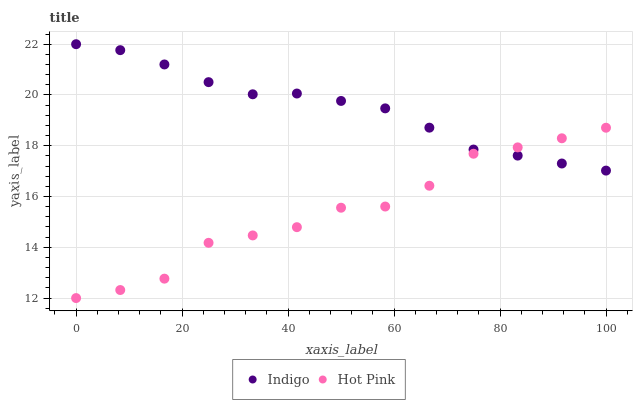Does Hot Pink have the minimum area under the curve?
Answer yes or no. Yes. Does Indigo have the maximum area under the curve?
Answer yes or no. Yes. Does Indigo have the minimum area under the curve?
Answer yes or no. No. Is Indigo the smoothest?
Answer yes or no. Yes. Is Hot Pink the roughest?
Answer yes or no. Yes. Is Indigo the roughest?
Answer yes or no. No. Does Hot Pink have the lowest value?
Answer yes or no. Yes. Does Indigo have the lowest value?
Answer yes or no. No. Does Indigo have the highest value?
Answer yes or no. Yes. Does Hot Pink intersect Indigo?
Answer yes or no. Yes. Is Hot Pink less than Indigo?
Answer yes or no. No. Is Hot Pink greater than Indigo?
Answer yes or no. No. 